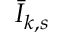<formula> <loc_0><loc_0><loc_500><loc_500>{ \bar { I } } _ { k , s }</formula> 